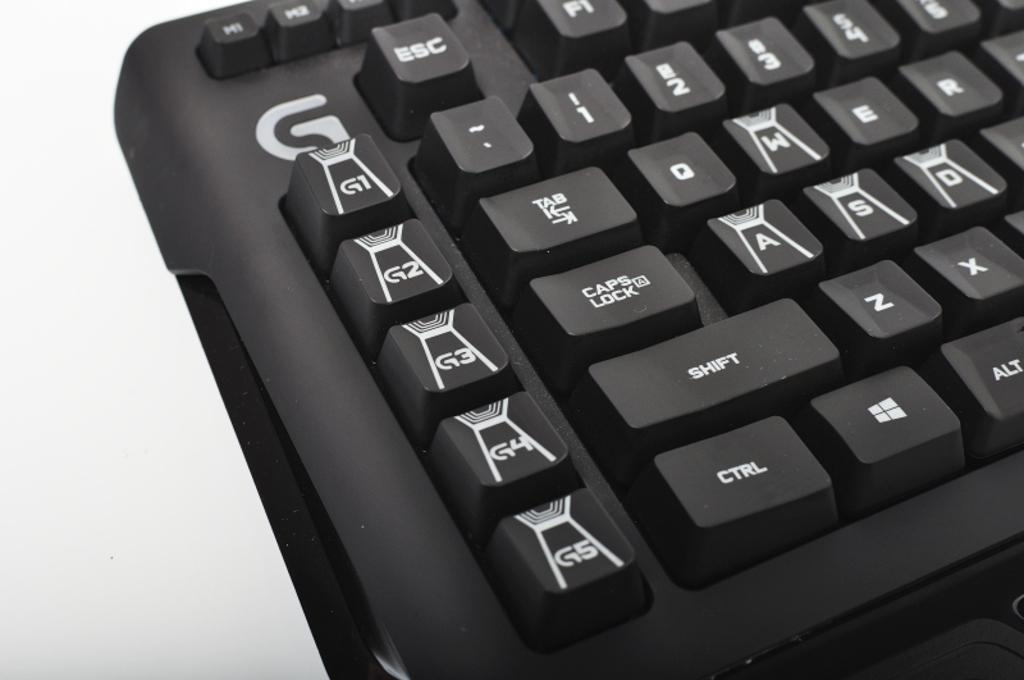<image>
Write a terse but informative summary of the picture. Different small keys are are placed under a G label on a keyboard. 